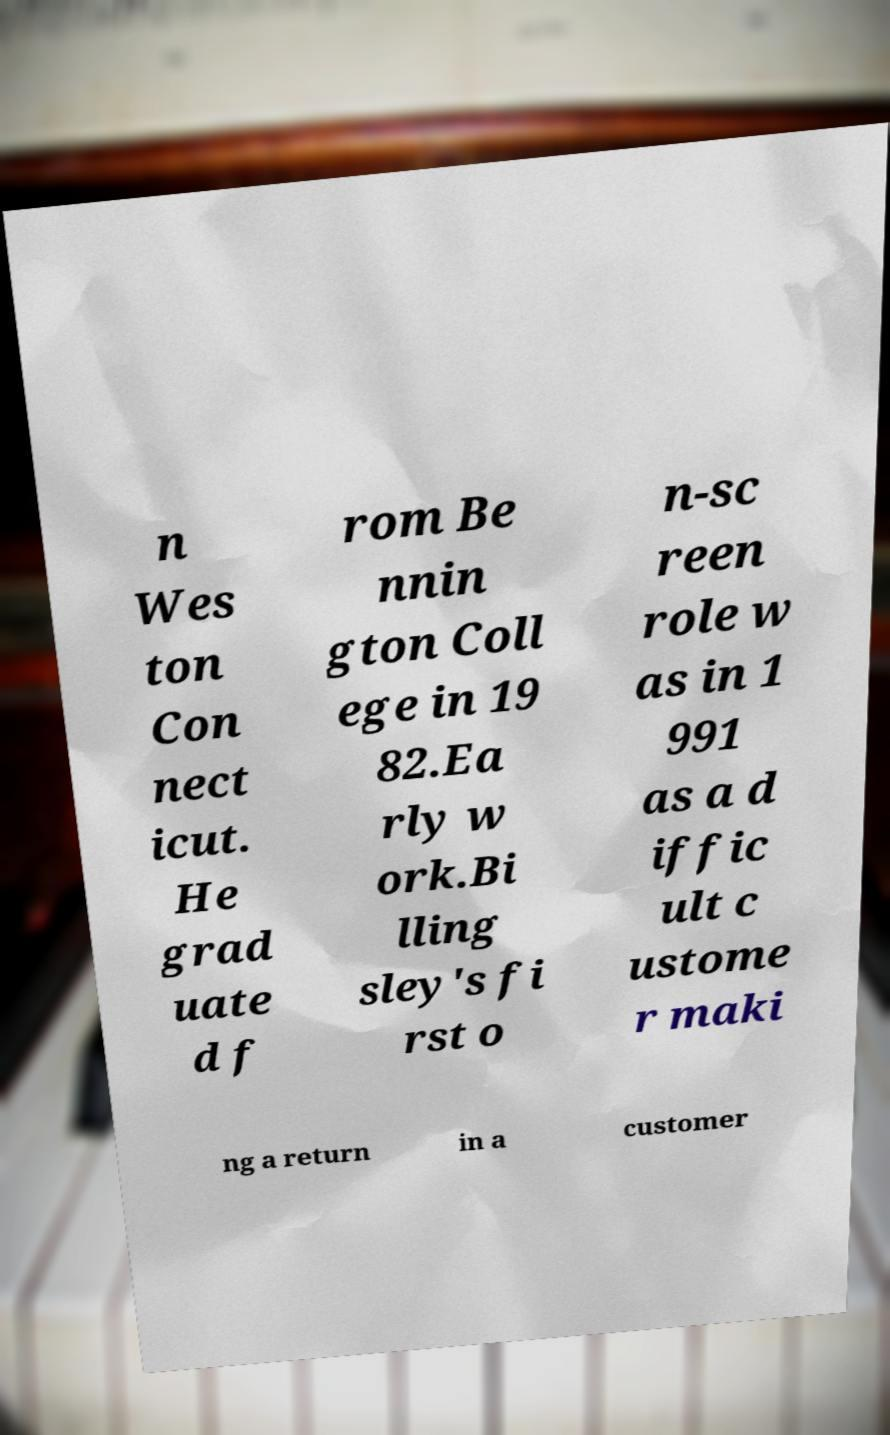For documentation purposes, I need the text within this image transcribed. Could you provide that? n Wes ton Con nect icut. He grad uate d f rom Be nnin gton Coll ege in 19 82.Ea rly w ork.Bi lling sley's fi rst o n-sc reen role w as in 1 991 as a d iffic ult c ustome r maki ng a return in a customer 